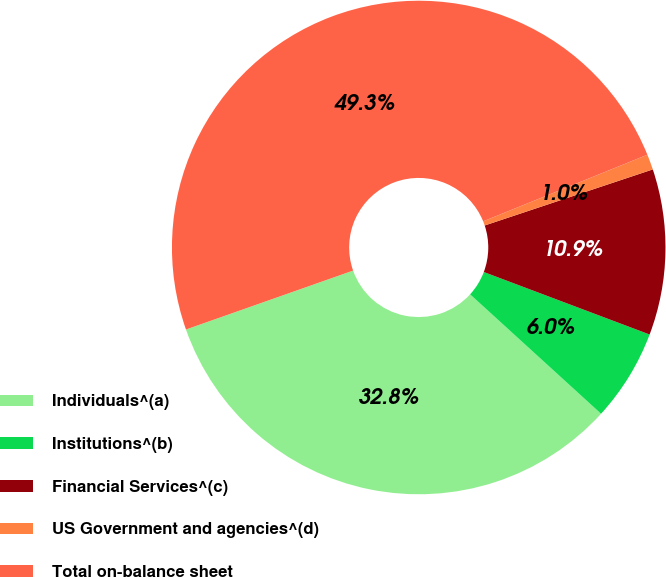Convert chart to OTSL. <chart><loc_0><loc_0><loc_500><loc_500><pie_chart><fcel>Individuals^(a)<fcel>Institutions^(b)<fcel>Financial Services^(c)<fcel>US Government and agencies^(d)<fcel>Total on-balance sheet<nl><fcel>32.84%<fcel>6.03%<fcel>10.86%<fcel>1.01%<fcel>49.26%<nl></chart> 